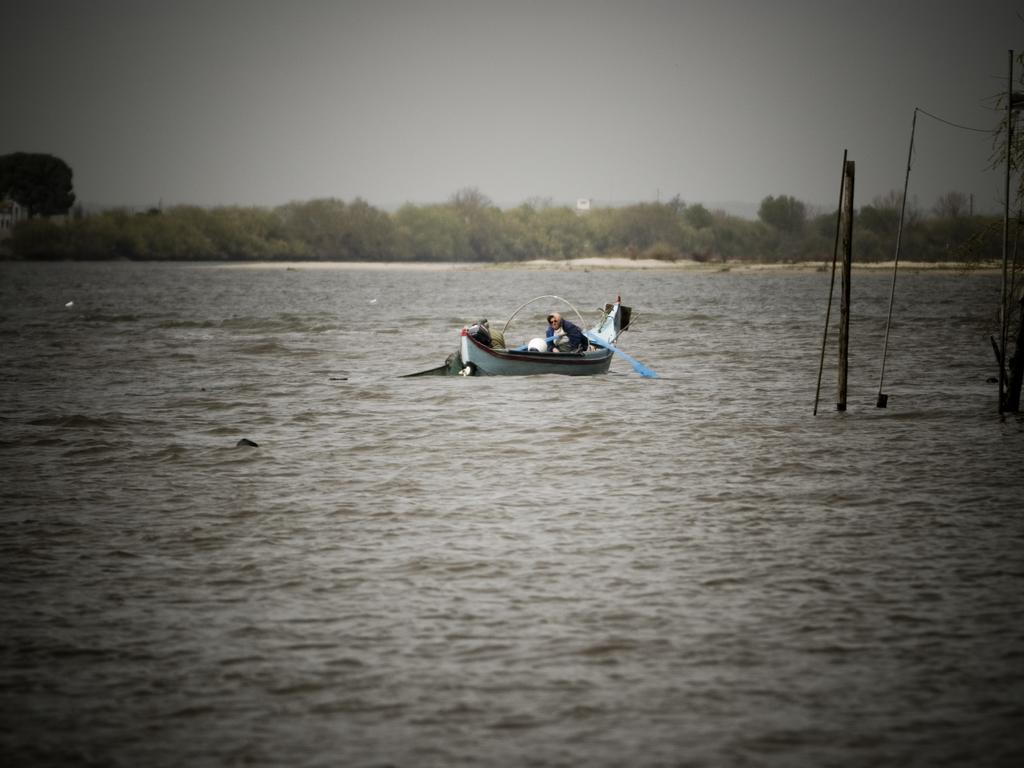Please provide a concise description of this image. In this image there is a boat sailing on the surface of the water. There is a person on the boat. He is holding a raft. Right side there are poles. Background there are trees. Top of the image there is sky. 